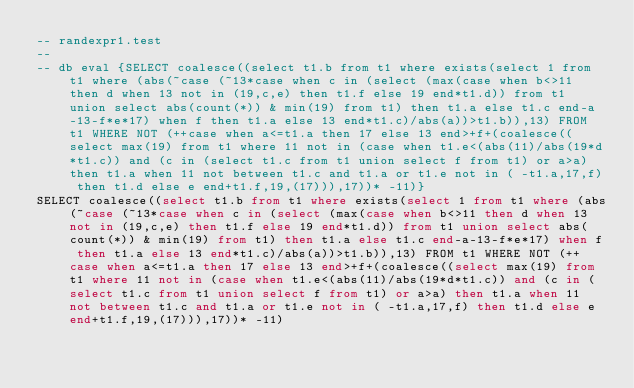Convert code to text. <code><loc_0><loc_0><loc_500><loc_500><_SQL_>-- randexpr1.test
-- 
-- db eval {SELECT coalesce((select t1.b from t1 where exists(select 1 from t1 where (abs(~case (~13*case when c in (select (max(case when b<>11 then d when 13 not in (19,c,e) then t1.f else 19 end*t1.d)) from t1 union select abs(count(*)) & min(19) from t1) then t1.a else t1.c end-a-13-f*e*17) when f then t1.a else 13 end*t1.c)/abs(a))>t1.b)),13) FROM t1 WHERE NOT (++case when a<=t1.a then 17 else 13 end>+f+(coalesce((select max(19) from t1 where 11 not in (case when t1.e<(abs(11)/abs(19*d*t1.c)) and (c in (select t1.c from t1 union select f from t1) or a>a) then t1.a when 11 not between t1.c and t1.a or t1.e not in ( -t1.a,17,f) then t1.d else e end+t1.f,19,(17))),17))* -11)}
SELECT coalesce((select t1.b from t1 where exists(select 1 from t1 where (abs(~case (~13*case when c in (select (max(case when b<>11 then d when 13 not in (19,c,e) then t1.f else 19 end*t1.d)) from t1 union select abs(count(*)) & min(19) from t1) then t1.a else t1.c end-a-13-f*e*17) when f then t1.a else 13 end*t1.c)/abs(a))>t1.b)),13) FROM t1 WHERE NOT (++case when a<=t1.a then 17 else 13 end>+f+(coalesce((select max(19) from t1 where 11 not in (case when t1.e<(abs(11)/abs(19*d*t1.c)) and (c in (select t1.c from t1 union select f from t1) or a>a) then t1.a when 11 not between t1.c and t1.a or t1.e not in ( -t1.a,17,f) then t1.d else e end+t1.f,19,(17))),17))* -11)</code> 